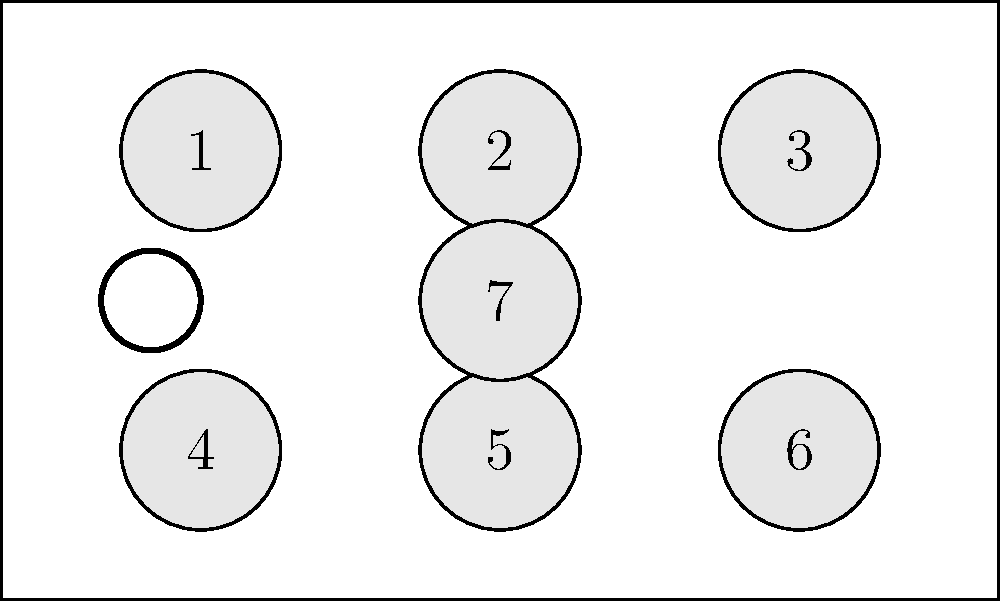In your 7-seater SUV, you're planning a road trip with friends. Consider the seating arrangements as permutations. If the driver's seat (labeled 1) is fixed, how many unique seating arrangements are possible for the remaining 6 passengers? Let's approach this step-by-step:

1) We have a 7-seater SUV with seats labeled 1 to 7, as shown in the diagram.

2) The driver's seat (seat 1) is fixed, meaning we don't include it in our permutation calculations.

3) We need to calculate the number of ways to arrange 6 people in the remaining 6 seats.

4) This is a straightforward permutation problem. We're arranging 6 distinct objects (passengers) into 6 distinct positions (seats).

5) The number of permutations of n distinct objects is given by the factorial of n, denoted as n!

6) In this case, n = 6

7) Therefore, the number of possible arrangements is 6!

8) 6! = 6 × 5 × 4 × 3 × 2 × 1 = 720

Thus, there are 720 unique seating arrangements possible for the 6 passengers in your 7-seater SUV, with the driver's seat fixed.
Answer: 720 